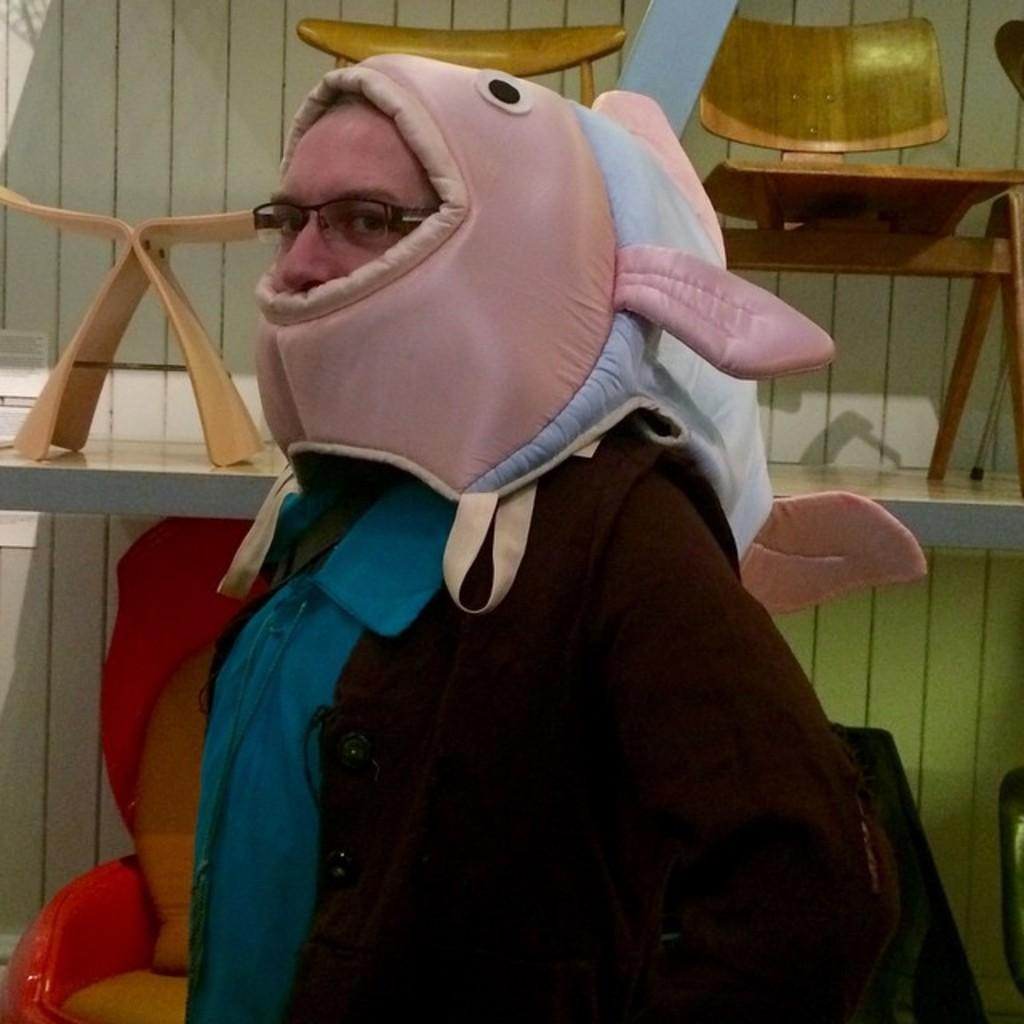What is present in the image? There is a person in the image. What can be seen in the background of the image? There are chairs in the background of the image. What color is the wall visible in the image? There is a white-colored wall in the image. What type of writer is present in the image? There is no writer present in the image; it only features a person and other elements. What is the person in the image using to serve food on a tray? There is no tray or food serving activity present in the image. 